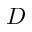Convert formula to latex. <formula><loc_0><loc_0><loc_500><loc_500>D</formula> 